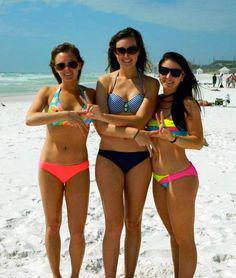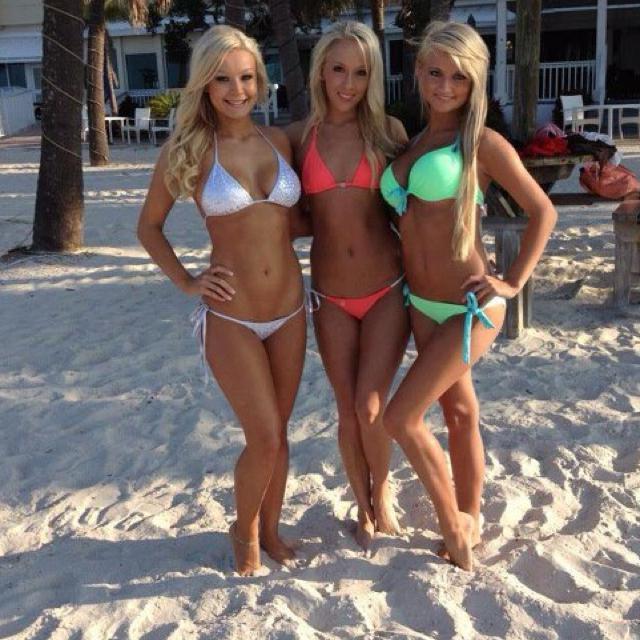The first image is the image on the left, the second image is the image on the right. Assess this claim about the two images: "An image shows three bikini models, with the one on the far right wearing a polka-dotted black top.". Correct or not? Answer yes or no. No. 